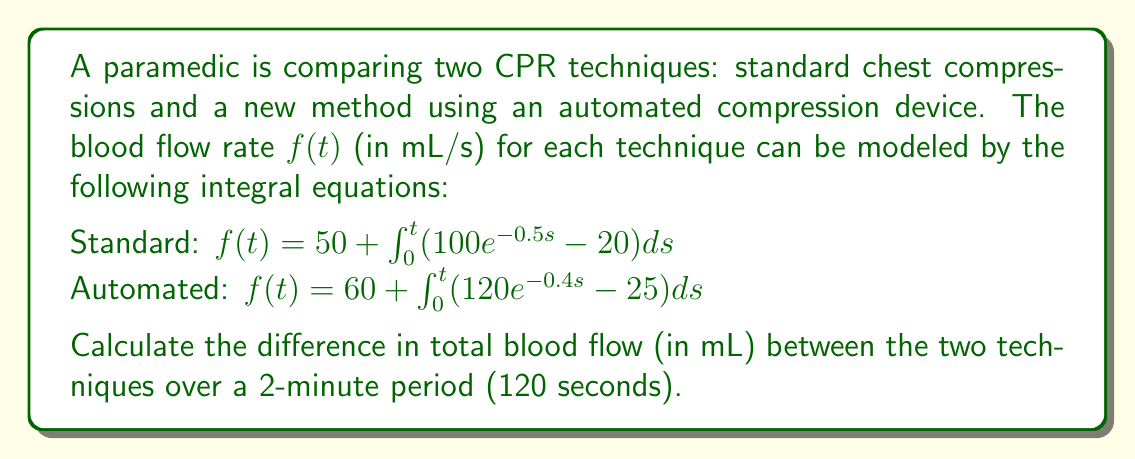Provide a solution to this math problem. To solve this problem, we need to follow these steps:

1. Solve the integral equations for both techniques:

For the standard technique:
$$f(t) = 50 + \int_0^t (100e^{-0.5s} - 20)ds$$
$$f(t) = 50 + [-200e^{-0.5s}]_0^t - 20t$$
$$f(t) = 50 - 200e^{-0.5t} + 200 - 20t$$
$$f(t) = 250 - 200e^{-0.5t} - 20t$$

For the automated technique:
$$f(t) = 60 + \int_0^t (120e^{-0.4s} - 25)ds$$
$$f(t) = 60 + [-300e^{-0.4s}]_0^t - 25t$$
$$f(t) = 60 - 300e^{-0.4t} + 300 - 25t$$
$$f(t) = 360 - 300e^{-0.4t} - 25t$$

2. Calculate the total blood flow for each technique by integrating the flow rate over 120 seconds:

For the standard technique:
$$\int_0^{120} (250 - 200e^{-0.5t} - 20t)dt$$
$$= [250t + 400e^{-0.5t} - 10t^2]_0^{120}$$
$$= (30000 + 400e^{-60} - 144000) - (0 + 400 - 0)$$
$$= 30000 + 400e^{-60} - 144000 - 400$$
$$= -114400 + 400e^{-60}$$

For the automated technique:
$$\int_0^{120} (360 - 300e^{-0.4t} - 25t)dt$$
$$= [360t + 750e^{-0.4t} - 12.5t^2]_0^{120}$$
$$= (43200 + 750e^{-48} - 180000) - (0 + 750 - 0)$$
$$= 43200 + 750e^{-48} - 180000 - 750$$
$$= -137550 + 750e^{-48}$$

3. Calculate the difference between the two techniques:
$$(-137550 + 750e^{-48}) - (-114400 + 400e^{-60})$$
$$= -23150 + 750e^{-48} - 400e^{-60}$$

This is the exact solution. For a numerical approximation:
$$\approx -23150 + 750 \cdot (3.793 \times 10^{-21}) - 400 \cdot (8.756 \times 10^{-27})$$
$$\approx -23150 + 2.845 \times 10^{-18} - 3.502 \times 10^{-24}$$
$$\approx -23150 \text{ mL}$$
Answer: $-23150 + 750e^{-48} - 400e^{-60}$ mL (≈ -23150 mL) 